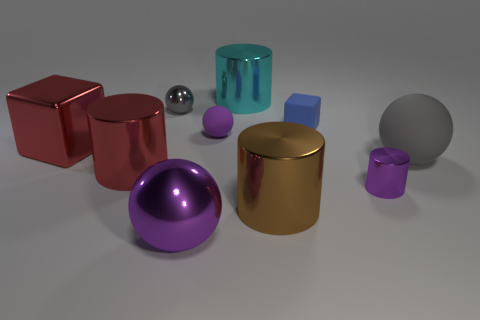Are there any patterns or consistency in the arrangement of these objects? The objects are arranged seemingly at random on a flat surface. However, one can note that spheres and cylinders are predominant shapes, presenting both a variety in size and color. The objects are placed with enough space between them to distinguish each one's shape clearly, which could suggest a deliberate placement for display or examination. 